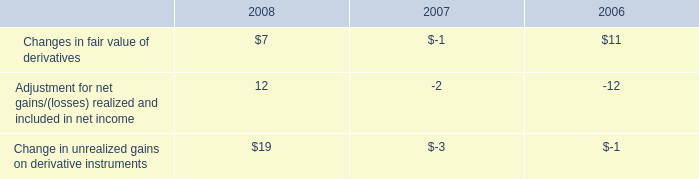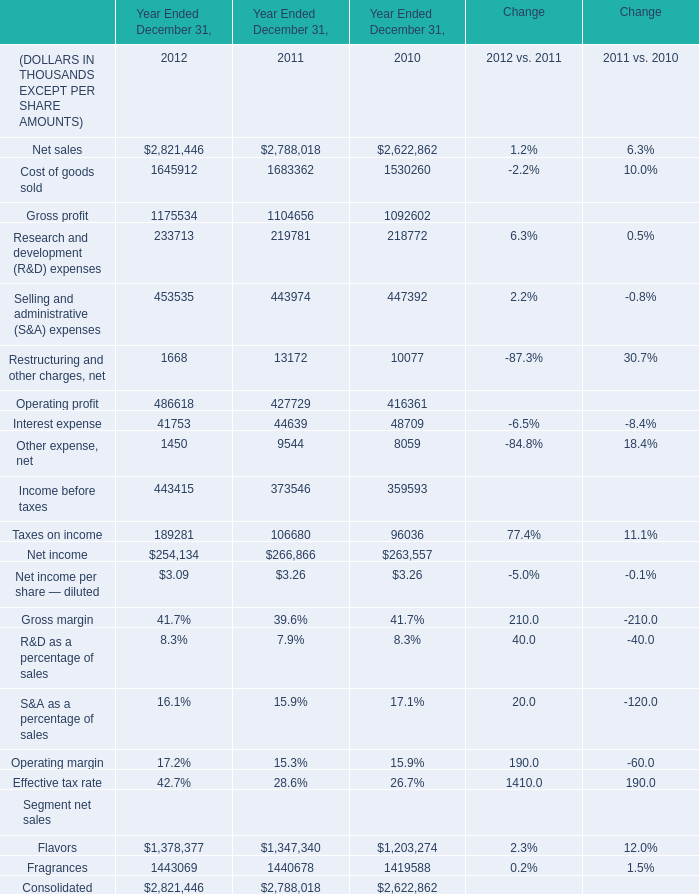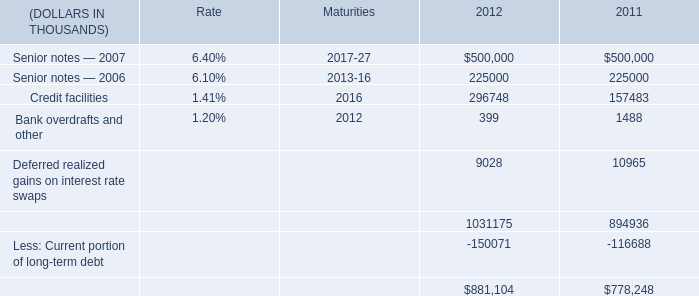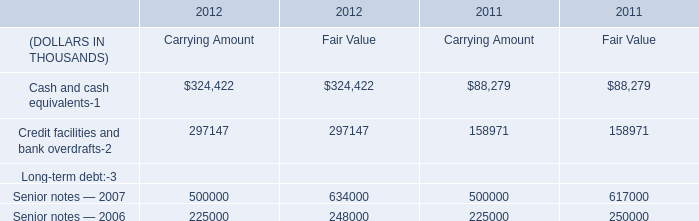In the year with the most Other expense, net, what is the growth rate of Income before taxes? 
Computations: ((443415 - 373546) / 373546)
Answer: 0.18704. 